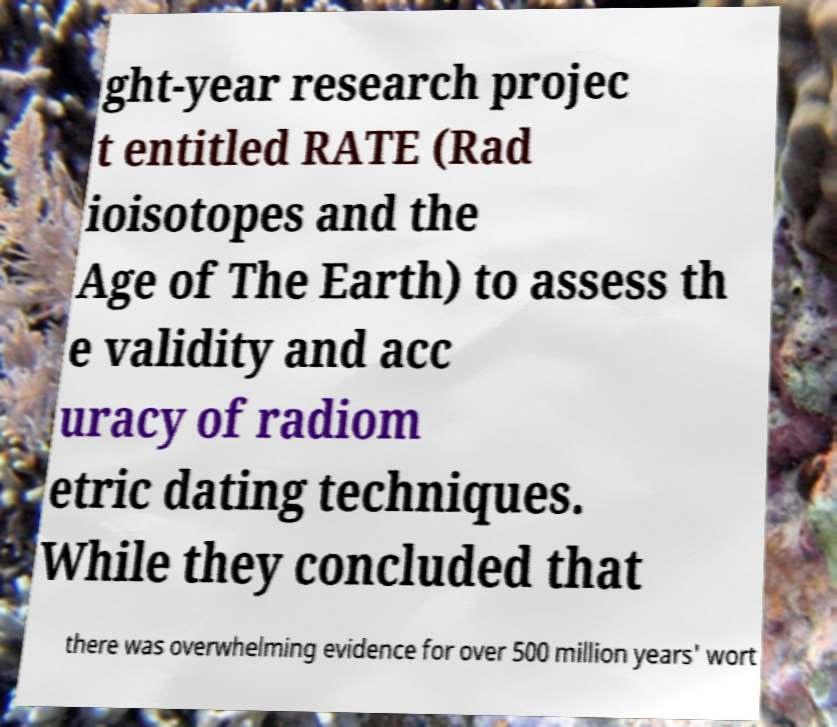Can you accurately transcribe the text from the provided image for me? ght-year research projec t entitled RATE (Rad ioisotopes and the Age of The Earth) to assess th e validity and acc uracy of radiom etric dating techniques. While they concluded that there was overwhelming evidence for over 500 million years' wort 